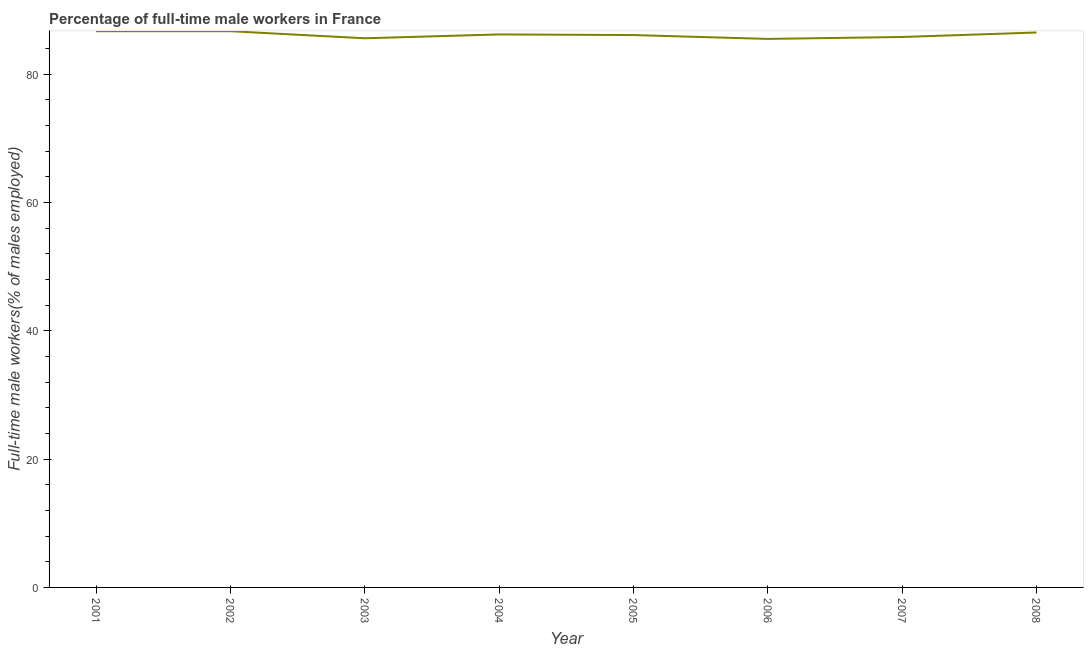What is the percentage of full-time male workers in 2006?
Make the answer very short. 85.5. Across all years, what is the maximum percentage of full-time male workers?
Your answer should be very brief. 86.7. Across all years, what is the minimum percentage of full-time male workers?
Provide a short and direct response. 85.5. In which year was the percentage of full-time male workers maximum?
Provide a succinct answer. 2001. What is the sum of the percentage of full-time male workers?
Ensure brevity in your answer.  689.1. What is the difference between the percentage of full-time male workers in 2003 and 2006?
Make the answer very short. 0.1. What is the average percentage of full-time male workers per year?
Offer a very short reply. 86.14. What is the median percentage of full-time male workers?
Your answer should be compact. 86.15. In how many years, is the percentage of full-time male workers greater than 72 %?
Provide a succinct answer. 8. What is the difference between the highest and the second highest percentage of full-time male workers?
Give a very brief answer. 0. Is the sum of the percentage of full-time male workers in 2001 and 2008 greater than the maximum percentage of full-time male workers across all years?
Keep it short and to the point. Yes. What is the difference between the highest and the lowest percentage of full-time male workers?
Offer a very short reply. 1.2. In how many years, is the percentage of full-time male workers greater than the average percentage of full-time male workers taken over all years?
Your response must be concise. 4. How many lines are there?
Your answer should be compact. 1. How many years are there in the graph?
Provide a short and direct response. 8. What is the difference between two consecutive major ticks on the Y-axis?
Offer a terse response. 20. Does the graph contain any zero values?
Ensure brevity in your answer.  No. What is the title of the graph?
Keep it short and to the point. Percentage of full-time male workers in France. What is the label or title of the Y-axis?
Ensure brevity in your answer.  Full-time male workers(% of males employed). What is the Full-time male workers(% of males employed) in 2001?
Provide a short and direct response. 86.7. What is the Full-time male workers(% of males employed) of 2002?
Offer a very short reply. 86.7. What is the Full-time male workers(% of males employed) of 2003?
Provide a short and direct response. 85.6. What is the Full-time male workers(% of males employed) in 2004?
Your response must be concise. 86.2. What is the Full-time male workers(% of males employed) of 2005?
Offer a very short reply. 86.1. What is the Full-time male workers(% of males employed) in 2006?
Give a very brief answer. 85.5. What is the Full-time male workers(% of males employed) of 2007?
Keep it short and to the point. 85.8. What is the Full-time male workers(% of males employed) of 2008?
Provide a short and direct response. 86.5. What is the difference between the Full-time male workers(% of males employed) in 2001 and 2004?
Provide a succinct answer. 0.5. What is the difference between the Full-time male workers(% of males employed) in 2001 and 2005?
Your answer should be very brief. 0.6. What is the difference between the Full-time male workers(% of males employed) in 2001 and 2007?
Offer a very short reply. 0.9. What is the difference between the Full-time male workers(% of males employed) in 2002 and 2003?
Provide a short and direct response. 1.1. What is the difference between the Full-time male workers(% of males employed) in 2002 and 2004?
Your answer should be compact. 0.5. What is the difference between the Full-time male workers(% of males employed) in 2002 and 2005?
Offer a terse response. 0.6. What is the difference between the Full-time male workers(% of males employed) in 2002 and 2006?
Your answer should be compact. 1.2. What is the difference between the Full-time male workers(% of males employed) in 2002 and 2007?
Offer a very short reply. 0.9. What is the difference between the Full-time male workers(% of males employed) in 2003 and 2004?
Provide a succinct answer. -0.6. What is the difference between the Full-time male workers(% of males employed) in 2003 and 2006?
Ensure brevity in your answer.  0.1. What is the difference between the Full-time male workers(% of males employed) in 2004 and 2007?
Ensure brevity in your answer.  0.4. What is the difference between the Full-time male workers(% of males employed) in 2005 and 2006?
Offer a terse response. 0.6. What is the difference between the Full-time male workers(% of males employed) in 2005 and 2007?
Ensure brevity in your answer.  0.3. What is the ratio of the Full-time male workers(% of males employed) in 2001 to that in 2003?
Provide a short and direct response. 1.01. What is the ratio of the Full-time male workers(% of males employed) in 2001 to that in 2004?
Your answer should be compact. 1.01. What is the ratio of the Full-time male workers(% of males employed) in 2001 to that in 2006?
Your answer should be compact. 1.01. What is the ratio of the Full-time male workers(% of males employed) in 2001 to that in 2007?
Your answer should be very brief. 1.01. What is the ratio of the Full-time male workers(% of males employed) in 2002 to that in 2003?
Your answer should be very brief. 1.01. What is the ratio of the Full-time male workers(% of males employed) in 2002 to that in 2004?
Provide a succinct answer. 1.01. What is the ratio of the Full-time male workers(% of males employed) in 2002 to that in 2007?
Your response must be concise. 1.01. What is the ratio of the Full-time male workers(% of males employed) in 2002 to that in 2008?
Ensure brevity in your answer.  1. What is the ratio of the Full-time male workers(% of males employed) in 2004 to that in 2006?
Keep it short and to the point. 1.01. What is the ratio of the Full-time male workers(% of males employed) in 2004 to that in 2007?
Your answer should be compact. 1. What is the ratio of the Full-time male workers(% of males employed) in 2005 to that in 2006?
Ensure brevity in your answer.  1.01. What is the ratio of the Full-time male workers(% of males employed) in 2005 to that in 2007?
Make the answer very short. 1. What is the ratio of the Full-time male workers(% of males employed) in 2005 to that in 2008?
Provide a succinct answer. 0.99. What is the ratio of the Full-time male workers(% of males employed) in 2006 to that in 2008?
Keep it short and to the point. 0.99. 